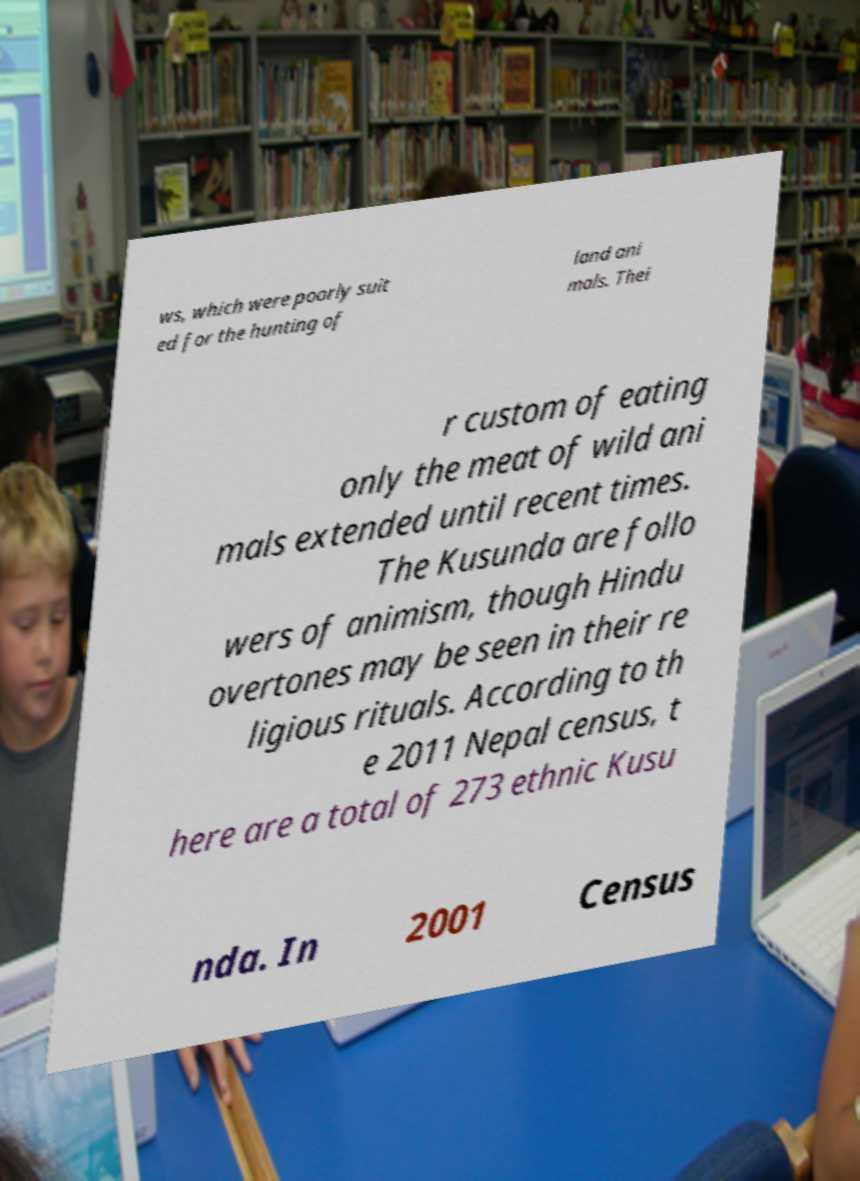I need the written content from this picture converted into text. Can you do that? ws, which were poorly suit ed for the hunting of land ani mals. Thei r custom of eating only the meat of wild ani mals extended until recent times. The Kusunda are follo wers of animism, though Hindu overtones may be seen in their re ligious rituals. According to th e 2011 Nepal census, t here are a total of 273 ethnic Kusu nda. In 2001 Census 